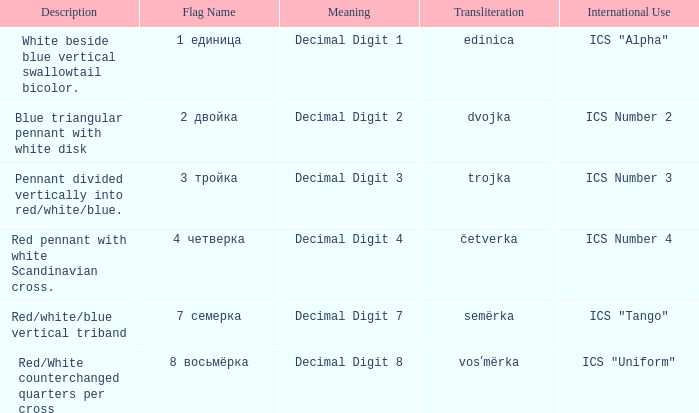What are the meanings of the flag whose name transliterates to semërka? Decimal Digit 7. 